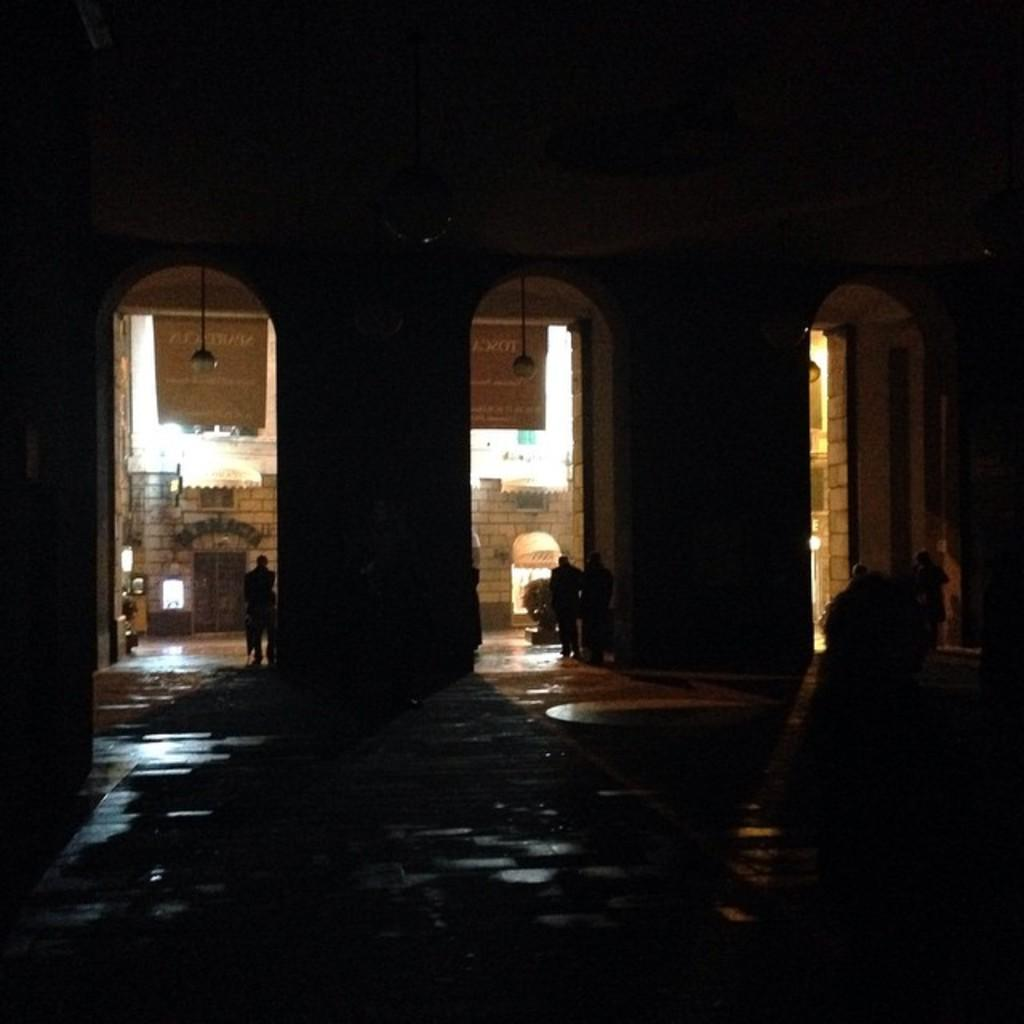What type of structure is present in the image? There is a building in the image. Can you describe the people inside the building? There are persons visible inside the building. What type of can is shown on the flower in the image? There is no can or flower present in the image; it only features a building and persons inside it. 